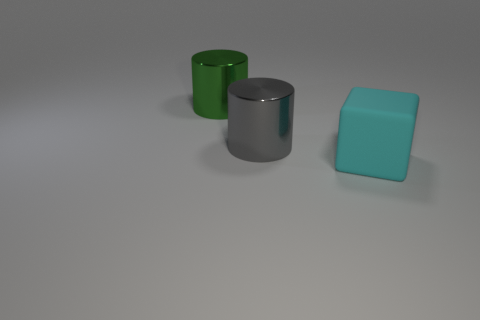Add 1 cylinders. How many objects exist? 4 Subtract all cylinders. How many objects are left? 1 Add 3 large cyan blocks. How many large cyan blocks are left? 4 Add 3 green shiny things. How many green shiny things exist? 4 Subtract 0 gray blocks. How many objects are left? 3 Subtract all large green metal spheres. Subtract all gray metallic things. How many objects are left? 2 